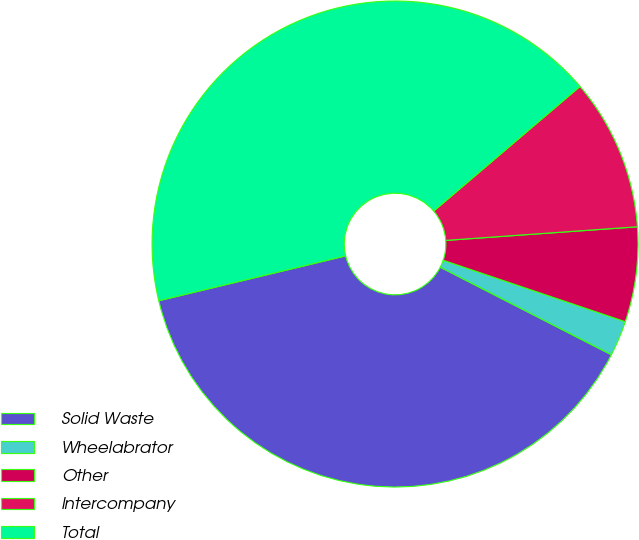Convert chart. <chart><loc_0><loc_0><loc_500><loc_500><pie_chart><fcel>Solid Waste<fcel>Wheelabrator<fcel>Other<fcel>Intercompany<fcel>Total<nl><fcel>38.72%<fcel>2.35%<fcel>6.31%<fcel>10.1%<fcel>42.52%<nl></chart> 